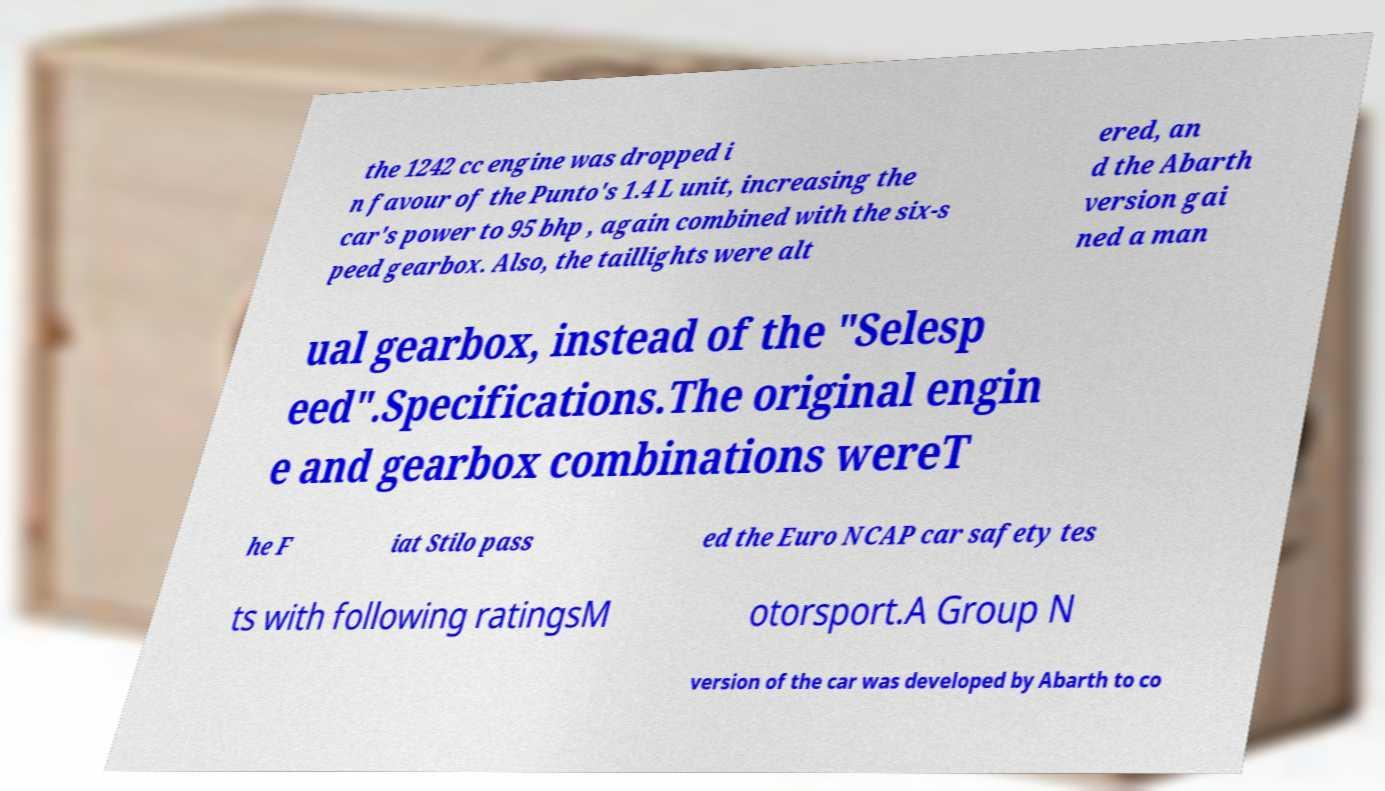There's text embedded in this image that I need extracted. Can you transcribe it verbatim? the 1242 cc engine was dropped i n favour of the Punto's 1.4 L unit, increasing the car's power to 95 bhp , again combined with the six-s peed gearbox. Also, the taillights were alt ered, an d the Abarth version gai ned a man ual gearbox, instead of the "Selesp eed".Specifications.The original engin e and gearbox combinations wereT he F iat Stilo pass ed the Euro NCAP car safety tes ts with following ratingsM otorsport.A Group N version of the car was developed by Abarth to co 